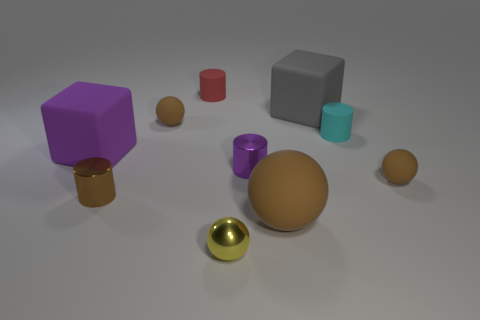Subtract all red blocks. How many brown spheres are left? 3 Subtract all blue cylinders. Subtract all brown cubes. How many cylinders are left? 4 Subtract all cubes. How many objects are left? 8 Subtract all small balls. Subtract all tiny brown matte things. How many objects are left? 5 Add 7 tiny yellow balls. How many tiny yellow balls are left? 8 Add 5 tiny green metal things. How many tiny green metal things exist? 5 Subtract 0 yellow blocks. How many objects are left? 10 